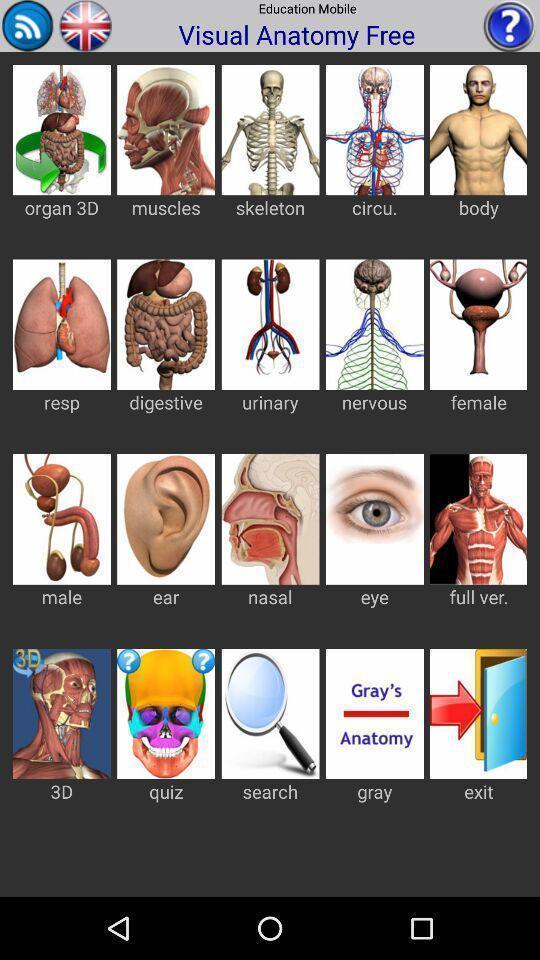Describe the content in this image. Screen displaying list of anatomy images. 